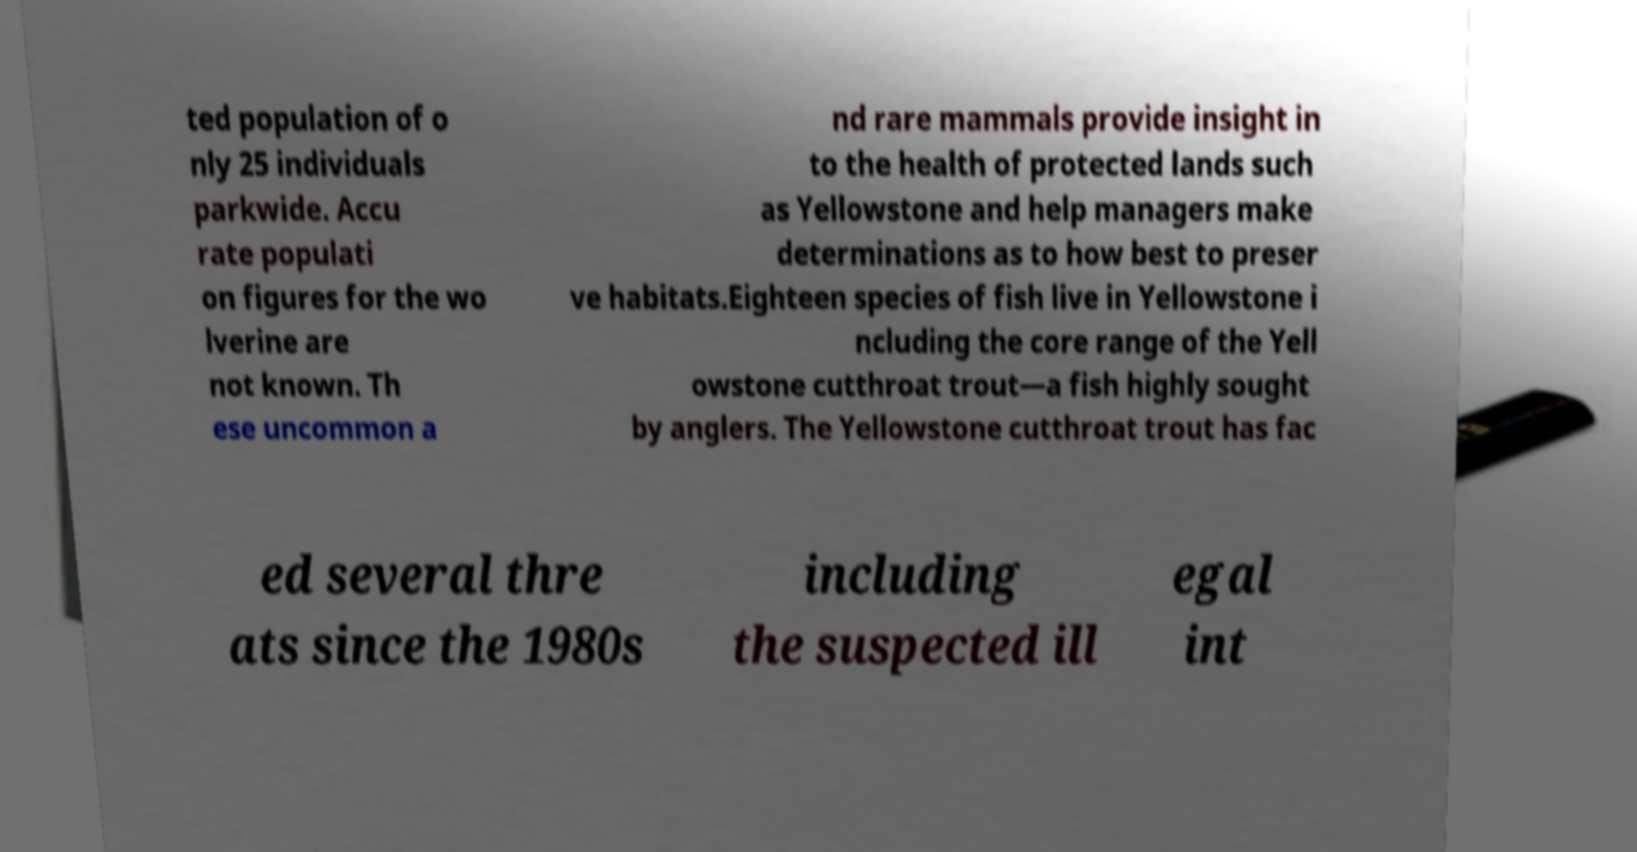Can you read and provide the text displayed in the image?This photo seems to have some interesting text. Can you extract and type it out for me? ted population of o nly 25 individuals parkwide. Accu rate populati on figures for the wo lverine are not known. Th ese uncommon a nd rare mammals provide insight in to the health of protected lands such as Yellowstone and help managers make determinations as to how best to preser ve habitats.Eighteen species of fish live in Yellowstone i ncluding the core range of the Yell owstone cutthroat trout—a fish highly sought by anglers. The Yellowstone cutthroat trout has fac ed several thre ats since the 1980s including the suspected ill egal int 